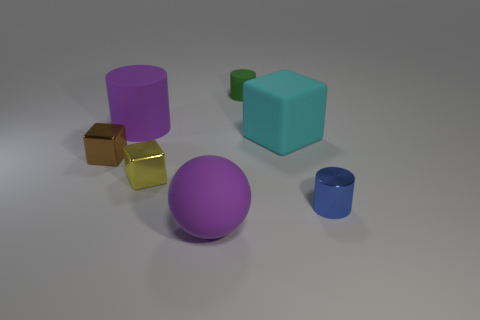What shape is the object that is the same color as the rubber ball?
Your answer should be compact. Cylinder. There is another tiny thing that is the same shape as the small yellow object; what is its color?
Offer a very short reply. Brown. What is the size of the brown shiny object that is the same shape as the yellow shiny object?
Make the answer very short. Small. There is a tiny cylinder in front of the small brown cube; what is its material?
Give a very brief answer. Metal. Is the number of large purple matte objects that are in front of the metallic cylinder less than the number of tiny blocks?
Your answer should be compact. Yes. There is a tiny object behind the cylinder that is left of the tiny rubber thing; what shape is it?
Provide a succinct answer. Cylinder. The matte ball is what color?
Keep it short and to the point. Purple. What number of other things are there of the same size as the cyan object?
Offer a terse response. 2. The thing that is on the right side of the tiny rubber cylinder and in front of the rubber cube is made of what material?
Ensure brevity in your answer.  Metal. There is a rubber block behind the yellow thing; is its size the same as the big matte cylinder?
Offer a very short reply. Yes. 